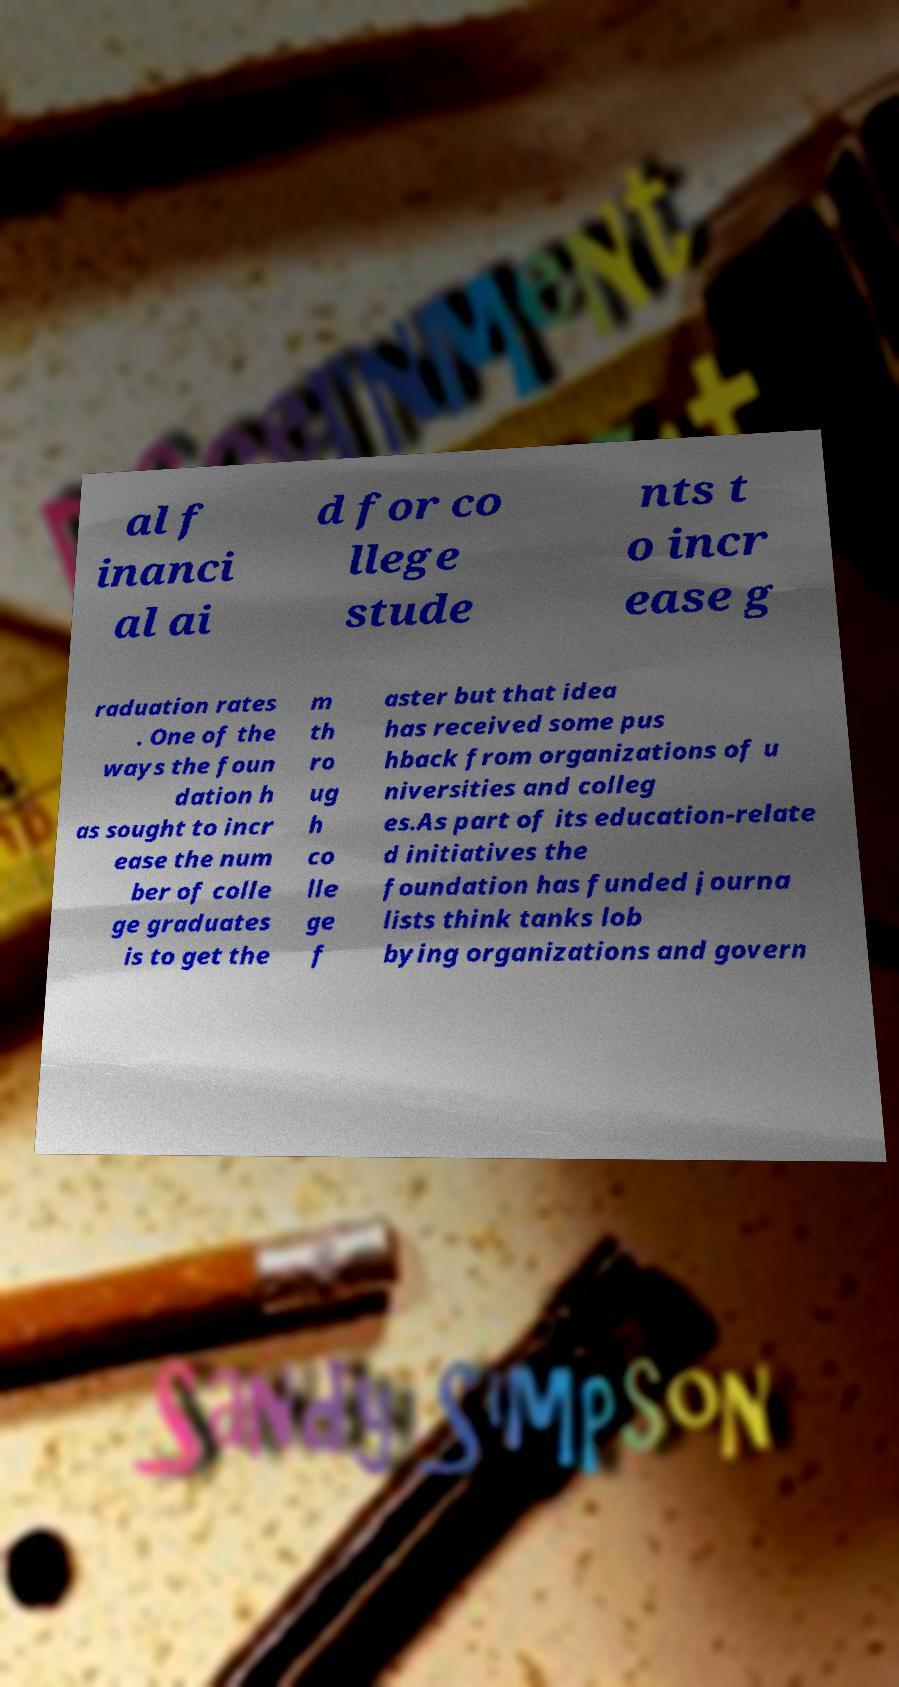Could you assist in decoding the text presented in this image and type it out clearly? al f inanci al ai d for co llege stude nts t o incr ease g raduation rates . One of the ways the foun dation h as sought to incr ease the num ber of colle ge graduates is to get the m th ro ug h co lle ge f aster but that idea has received some pus hback from organizations of u niversities and colleg es.As part of its education-relate d initiatives the foundation has funded journa lists think tanks lob bying organizations and govern 